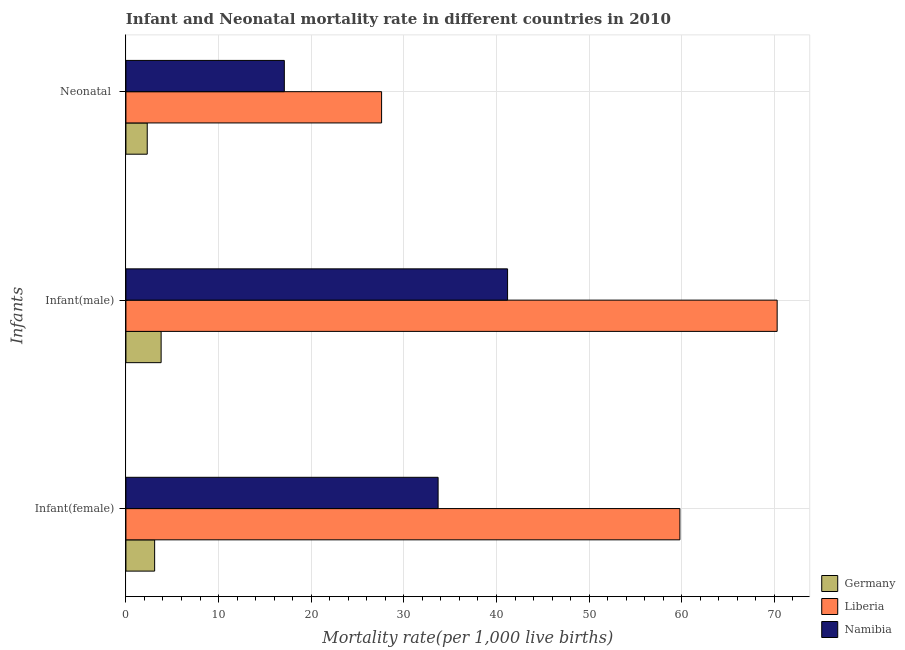Are the number of bars per tick equal to the number of legend labels?
Give a very brief answer. Yes. How many bars are there on the 1st tick from the top?
Your answer should be very brief. 3. How many bars are there on the 1st tick from the bottom?
Your response must be concise. 3. What is the label of the 1st group of bars from the top?
Your answer should be very brief. Neonatal . What is the infant mortality rate(female) in Germany?
Give a very brief answer. 3.1. Across all countries, what is the maximum neonatal mortality rate?
Provide a short and direct response. 27.6. In which country was the infant mortality rate(male) maximum?
Your response must be concise. Liberia. What is the total neonatal mortality rate in the graph?
Make the answer very short. 47. What is the difference between the infant mortality rate(female) in Liberia and that in Namibia?
Your response must be concise. 26.1. What is the difference between the neonatal mortality rate in Namibia and the infant mortality rate(female) in Germany?
Give a very brief answer. 14. What is the average neonatal mortality rate per country?
Make the answer very short. 15.67. What is the difference between the neonatal mortality rate and infant mortality rate(male) in Liberia?
Your answer should be very brief. -42.7. What is the ratio of the neonatal mortality rate in Liberia to that in Namibia?
Your answer should be compact. 1.61. Is the infant mortality rate(male) in Liberia less than that in Namibia?
Provide a succinct answer. No. Is the difference between the neonatal mortality rate in Liberia and Namibia greater than the difference between the infant mortality rate(female) in Liberia and Namibia?
Your answer should be compact. No. What is the difference between the highest and the second highest neonatal mortality rate?
Make the answer very short. 10.5. What is the difference between the highest and the lowest infant mortality rate(female)?
Give a very brief answer. 56.7. What does the 1st bar from the top in Infant(female) represents?
Provide a succinct answer. Namibia. What does the 3rd bar from the bottom in Infant(female) represents?
Your response must be concise. Namibia. Are all the bars in the graph horizontal?
Offer a very short reply. Yes. How many countries are there in the graph?
Offer a terse response. 3. Does the graph contain grids?
Your answer should be compact. Yes. Where does the legend appear in the graph?
Your answer should be very brief. Bottom right. What is the title of the graph?
Offer a very short reply. Infant and Neonatal mortality rate in different countries in 2010. Does "Canada" appear as one of the legend labels in the graph?
Your answer should be very brief. No. What is the label or title of the X-axis?
Offer a terse response. Mortality rate(per 1,0 live births). What is the label or title of the Y-axis?
Offer a terse response. Infants. What is the Mortality rate(per 1,000 live births) in Germany in Infant(female)?
Your answer should be very brief. 3.1. What is the Mortality rate(per 1,000 live births) of Liberia in Infant(female)?
Keep it short and to the point. 59.8. What is the Mortality rate(per 1,000 live births) of Namibia in Infant(female)?
Ensure brevity in your answer.  33.7. What is the Mortality rate(per 1,000 live births) in Liberia in Infant(male)?
Provide a succinct answer. 70.3. What is the Mortality rate(per 1,000 live births) of Namibia in Infant(male)?
Ensure brevity in your answer.  41.2. What is the Mortality rate(per 1,000 live births) of Germany in Neonatal ?
Your response must be concise. 2.3. What is the Mortality rate(per 1,000 live births) of Liberia in Neonatal ?
Give a very brief answer. 27.6. What is the Mortality rate(per 1,000 live births) in Namibia in Neonatal ?
Offer a terse response. 17.1. Across all Infants, what is the maximum Mortality rate(per 1,000 live births) of Liberia?
Provide a short and direct response. 70.3. Across all Infants, what is the maximum Mortality rate(per 1,000 live births) of Namibia?
Make the answer very short. 41.2. Across all Infants, what is the minimum Mortality rate(per 1,000 live births) in Germany?
Your answer should be very brief. 2.3. Across all Infants, what is the minimum Mortality rate(per 1,000 live births) in Liberia?
Provide a short and direct response. 27.6. What is the total Mortality rate(per 1,000 live births) of Germany in the graph?
Offer a very short reply. 9.2. What is the total Mortality rate(per 1,000 live births) in Liberia in the graph?
Provide a short and direct response. 157.7. What is the total Mortality rate(per 1,000 live births) in Namibia in the graph?
Your answer should be very brief. 92. What is the difference between the Mortality rate(per 1,000 live births) in Germany in Infant(female) and that in Infant(male)?
Offer a terse response. -0.7. What is the difference between the Mortality rate(per 1,000 live births) of Germany in Infant(female) and that in Neonatal ?
Your response must be concise. 0.8. What is the difference between the Mortality rate(per 1,000 live births) in Liberia in Infant(female) and that in Neonatal ?
Give a very brief answer. 32.2. What is the difference between the Mortality rate(per 1,000 live births) in Namibia in Infant(female) and that in Neonatal ?
Offer a terse response. 16.6. What is the difference between the Mortality rate(per 1,000 live births) in Germany in Infant(male) and that in Neonatal ?
Your answer should be very brief. 1.5. What is the difference between the Mortality rate(per 1,000 live births) in Liberia in Infant(male) and that in Neonatal ?
Give a very brief answer. 42.7. What is the difference between the Mortality rate(per 1,000 live births) in Namibia in Infant(male) and that in Neonatal ?
Ensure brevity in your answer.  24.1. What is the difference between the Mortality rate(per 1,000 live births) in Germany in Infant(female) and the Mortality rate(per 1,000 live births) in Liberia in Infant(male)?
Your answer should be very brief. -67.2. What is the difference between the Mortality rate(per 1,000 live births) in Germany in Infant(female) and the Mortality rate(per 1,000 live births) in Namibia in Infant(male)?
Your answer should be compact. -38.1. What is the difference between the Mortality rate(per 1,000 live births) of Germany in Infant(female) and the Mortality rate(per 1,000 live births) of Liberia in Neonatal ?
Keep it short and to the point. -24.5. What is the difference between the Mortality rate(per 1,000 live births) in Germany in Infant(female) and the Mortality rate(per 1,000 live births) in Namibia in Neonatal ?
Your answer should be compact. -14. What is the difference between the Mortality rate(per 1,000 live births) of Liberia in Infant(female) and the Mortality rate(per 1,000 live births) of Namibia in Neonatal ?
Your response must be concise. 42.7. What is the difference between the Mortality rate(per 1,000 live births) of Germany in Infant(male) and the Mortality rate(per 1,000 live births) of Liberia in Neonatal ?
Provide a short and direct response. -23.8. What is the difference between the Mortality rate(per 1,000 live births) in Germany in Infant(male) and the Mortality rate(per 1,000 live births) in Namibia in Neonatal ?
Give a very brief answer. -13.3. What is the difference between the Mortality rate(per 1,000 live births) in Liberia in Infant(male) and the Mortality rate(per 1,000 live births) in Namibia in Neonatal ?
Your answer should be compact. 53.2. What is the average Mortality rate(per 1,000 live births) of Germany per Infants?
Give a very brief answer. 3.07. What is the average Mortality rate(per 1,000 live births) in Liberia per Infants?
Make the answer very short. 52.57. What is the average Mortality rate(per 1,000 live births) in Namibia per Infants?
Offer a terse response. 30.67. What is the difference between the Mortality rate(per 1,000 live births) in Germany and Mortality rate(per 1,000 live births) in Liberia in Infant(female)?
Your response must be concise. -56.7. What is the difference between the Mortality rate(per 1,000 live births) in Germany and Mortality rate(per 1,000 live births) in Namibia in Infant(female)?
Make the answer very short. -30.6. What is the difference between the Mortality rate(per 1,000 live births) of Liberia and Mortality rate(per 1,000 live births) of Namibia in Infant(female)?
Your answer should be very brief. 26.1. What is the difference between the Mortality rate(per 1,000 live births) of Germany and Mortality rate(per 1,000 live births) of Liberia in Infant(male)?
Offer a terse response. -66.5. What is the difference between the Mortality rate(per 1,000 live births) of Germany and Mortality rate(per 1,000 live births) of Namibia in Infant(male)?
Your answer should be very brief. -37.4. What is the difference between the Mortality rate(per 1,000 live births) in Liberia and Mortality rate(per 1,000 live births) in Namibia in Infant(male)?
Your response must be concise. 29.1. What is the difference between the Mortality rate(per 1,000 live births) in Germany and Mortality rate(per 1,000 live births) in Liberia in Neonatal ?
Offer a very short reply. -25.3. What is the difference between the Mortality rate(per 1,000 live births) in Germany and Mortality rate(per 1,000 live births) in Namibia in Neonatal ?
Your response must be concise. -14.8. What is the ratio of the Mortality rate(per 1,000 live births) in Germany in Infant(female) to that in Infant(male)?
Give a very brief answer. 0.82. What is the ratio of the Mortality rate(per 1,000 live births) in Liberia in Infant(female) to that in Infant(male)?
Your answer should be compact. 0.85. What is the ratio of the Mortality rate(per 1,000 live births) of Namibia in Infant(female) to that in Infant(male)?
Offer a very short reply. 0.82. What is the ratio of the Mortality rate(per 1,000 live births) of Germany in Infant(female) to that in Neonatal ?
Offer a terse response. 1.35. What is the ratio of the Mortality rate(per 1,000 live births) of Liberia in Infant(female) to that in Neonatal ?
Offer a terse response. 2.17. What is the ratio of the Mortality rate(per 1,000 live births) in Namibia in Infant(female) to that in Neonatal ?
Ensure brevity in your answer.  1.97. What is the ratio of the Mortality rate(per 1,000 live births) of Germany in Infant(male) to that in Neonatal ?
Offer a terse response. 1.65. What is the ratio of the Mortality rate(per 1,000 live births) in Liberia in Infant(male) to that in Neonatal ?
Make the answer very short. 2.55. What is the ratio of the Mortality rate(per 1,000 live births) in Namibia in Infant(male) to that in Neonatal ?
Your response must be concise. 2.41. What is the difference between the highest and the second highest Mortality rate(per 1,000 live births) of Germany?
Your answer should be compact. 0.7. What is the difference between the highest and the lowest Mortality rate(per 1,000 live births) of Liberia?
Provide a short and direct response. 42.7. What is the difference between the highest and the lowest Mortality rate(per 1,000 live births) in Namibia?
Make the answer very short. 24.1. 